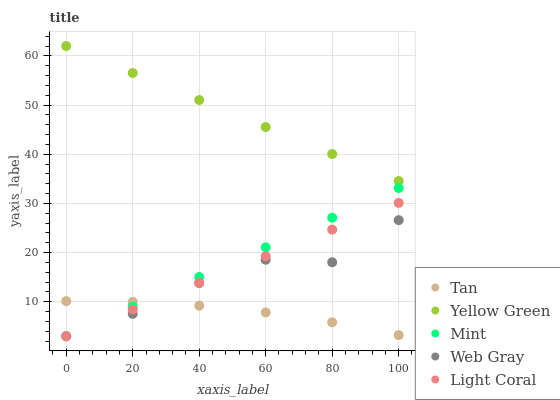Does Tan have the minimum area under the curve?
Answer yes or no. Yes. Does Yellow Green have the maximum area under the curve?
Answer yes or no. Yes. Does Web Gray have the minimum area under the curve?
Answer yes or no. No. Does Web Gray have the maximum area under the curve?
Answer yes or no. No. Is Light Coral the smoothest?
Answer yes or no. Yes. Is Web Gray the roughest?
Answer yes or no. Yes. Is Tan the smoothest?
Answer yes or no. No. Is Tan the roughest?
Answer yes or no. No. Does Light Coral have the lowest value?
Answer yes or no. Yes. Does Tan have the lowest value?
Answer yes or no. No. Does Yellow Green have the highest value?
Answer yes or no. Yes. Does Web Gray have the highest value?
Answer yes or no. No. Is Web Gray less than Yellow Green?
Answer yes or no. Yes. Is Yellow Green greater than Mint?
Answer yes or no. Yes. Does Light Coral intersect Tan?
Answer yes or no. Yes. Is Light Coral less than Tan?
Answer yes or no. No. Is Light Coral greater than Tan?
Answer yes or no. No. Does Web Gray intersect Yellow Green?
Answer yes or no. No. 